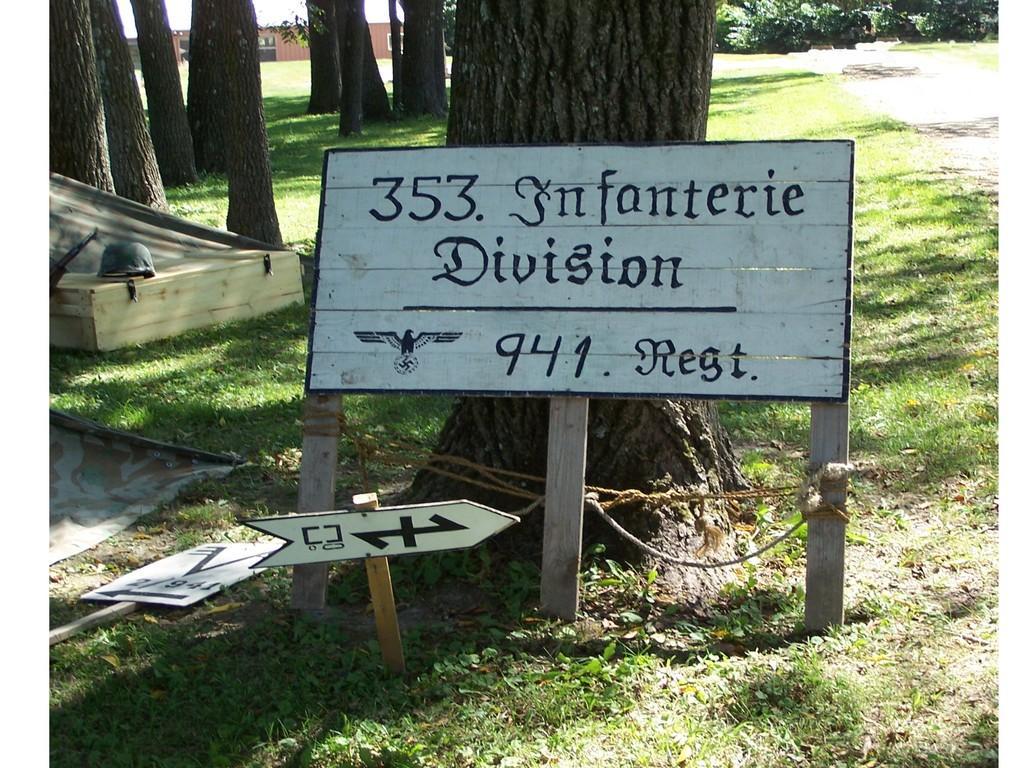Can you describe this image briefly? In this image there are trees truncated towards the top of the image, there is the wall, there are objects truncated towards the left of the image, there is a board, there is text on the board, there is the grass, there are plants, there is a board truncated towards the left of the image. 